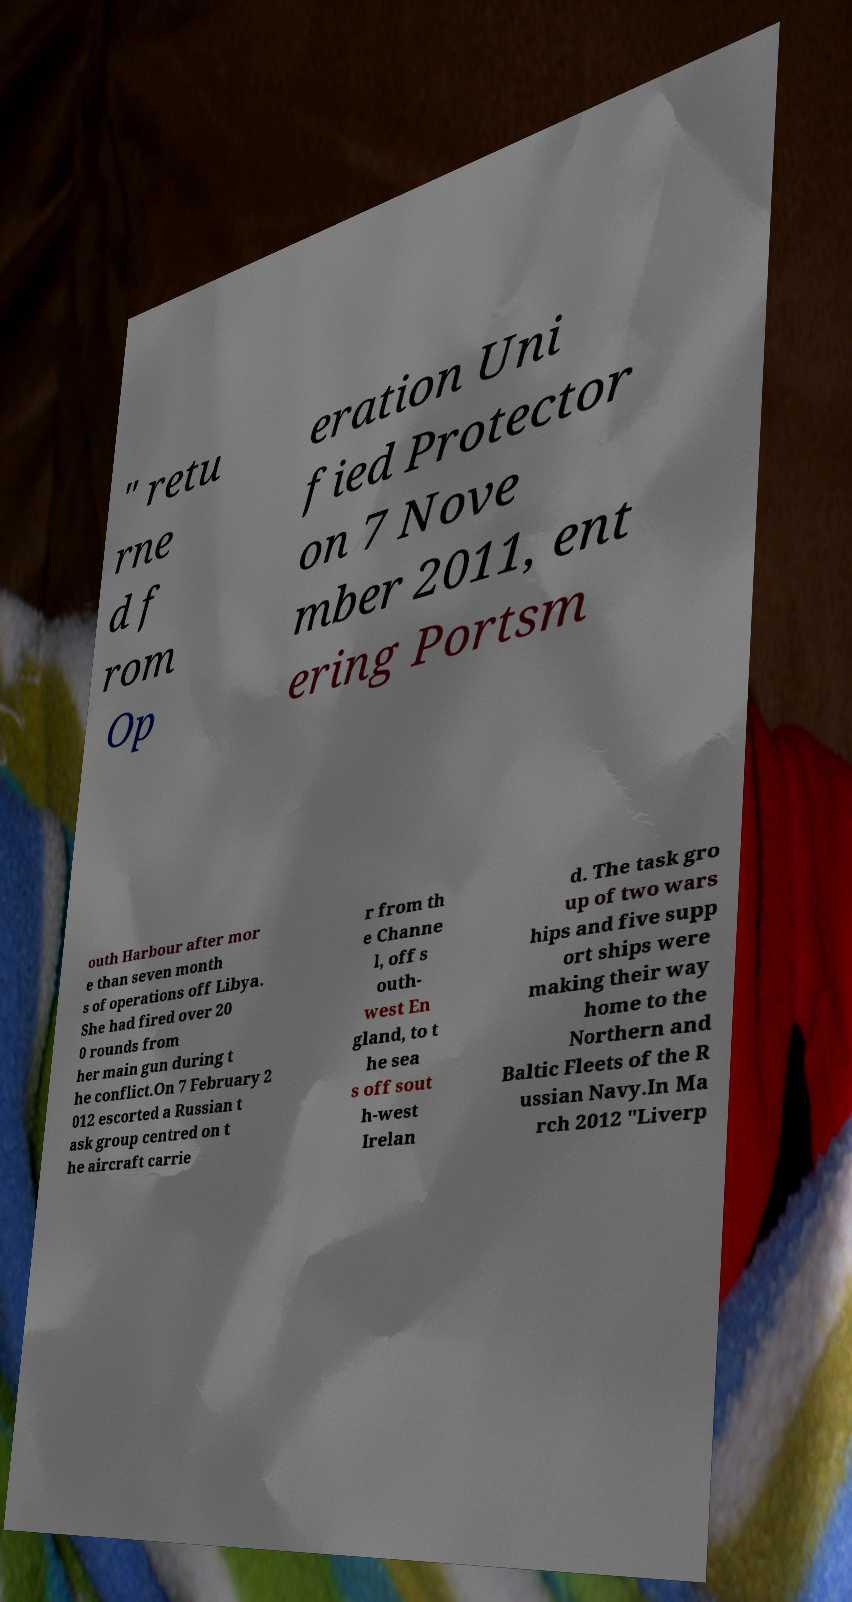What messages or text are displayed in this image? I need them in a readable, typed format. " retu rne d f rom Op eration Uni fied Protector on 7 Nove mber 2011, ent ering Portsm outh Harbour after mor e than seven month s of operations off Libya. She had fired over 20 0 rounds from her main gun during t he conflict.On 7 February 2 012 escorted a Russian t ask group centred on t he aircraft carrie r from th e Channe l, off s outh- west En gland, to t he sea s off sout h-west Irelan d. The task gro up of two wars hips and five supp ort ships were making their way home to the Northern and Baltic Fleets of the R ussian Navy.In Ma rch 2012 "Liverp 